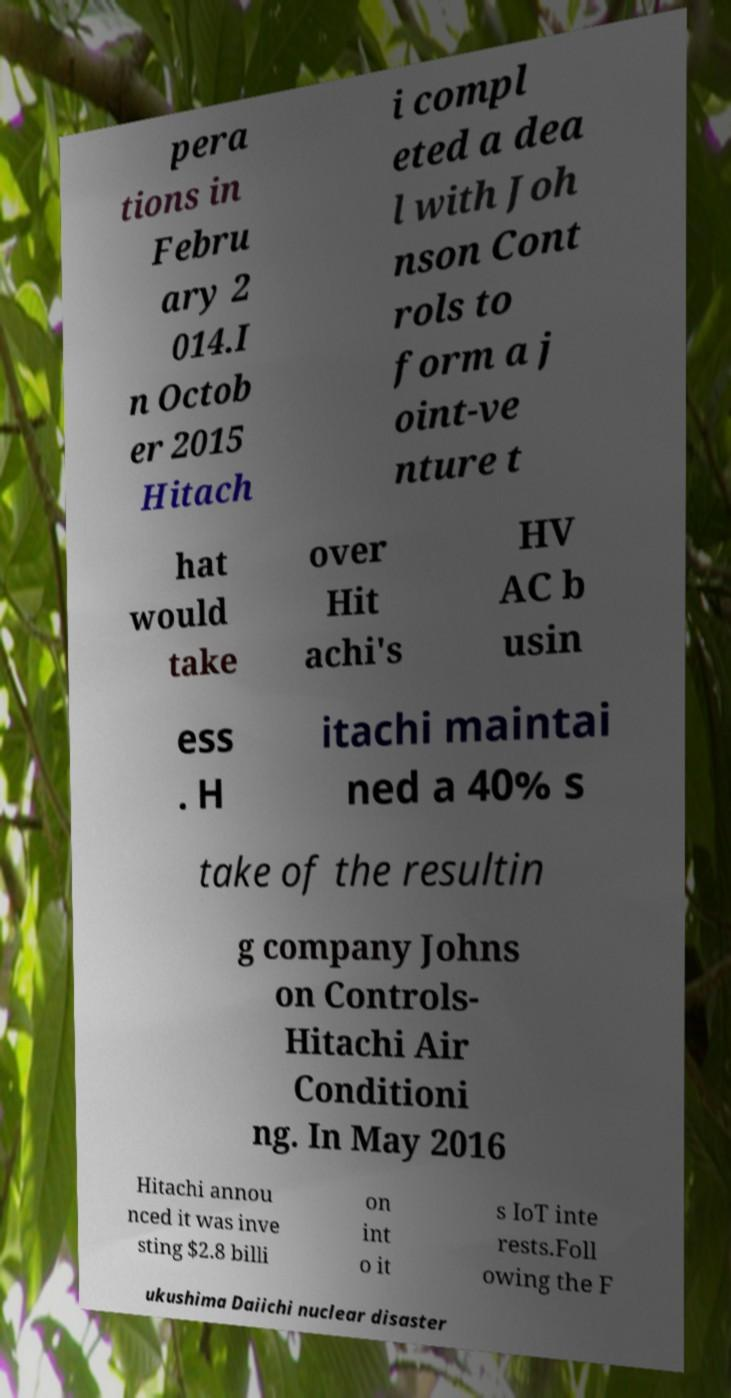I need the written content from this picture converted into text. Can you do that? pera tions in Febru ary 2 014.I n Octob er 2015 Hitach i compl eted a dea l with Joh nson Cont rols to form a j oint-ve nture t hat would take over Hit achi's HV AC b usin ess . H itachi maintai ned a 40% s take of the resultin g company Johns on Controls- Hitachi Air Conditioni ng. In May 2016 Hitachi annou nced it was inve sting $2.8 billi on int o it s IoT inte rests.Foll owing the F ukushima Daiichi nuclear disaster 